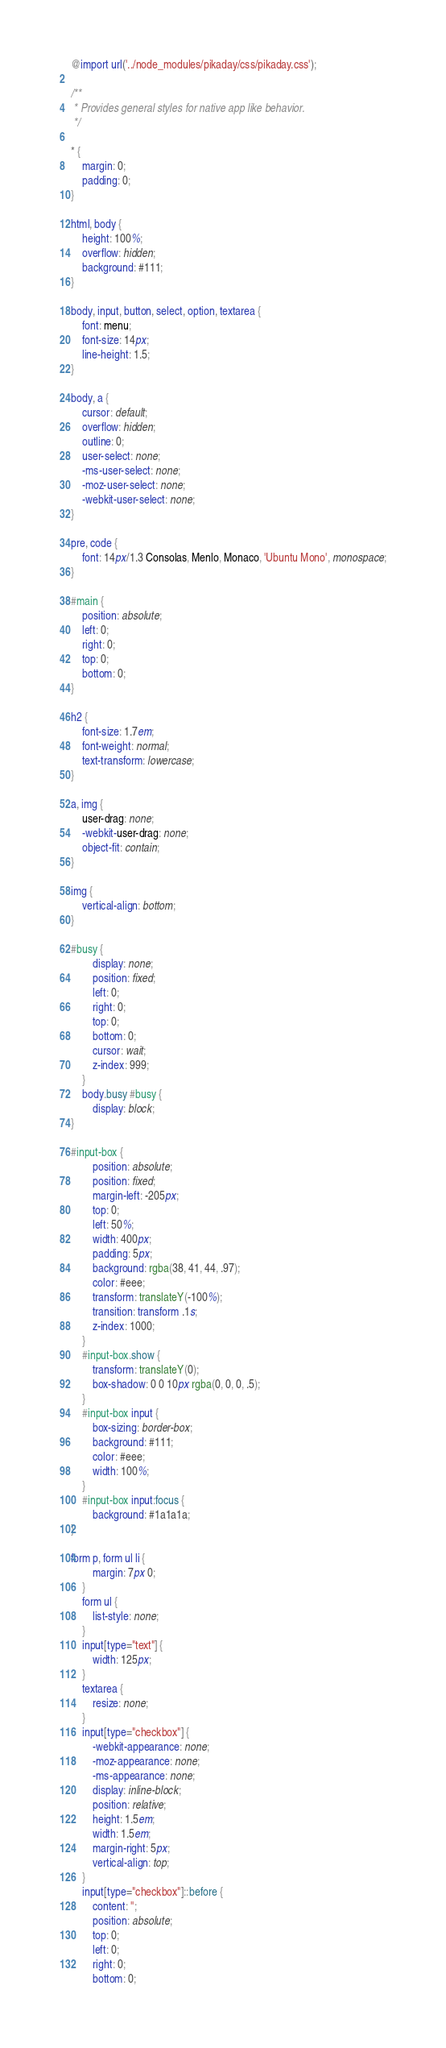<code> <loc_0><loc_0><loc_500><loc_500><_CSS_>@import url('../node_modules/pikaday/css/pikaday.css');

/**
 * Provides general styles for native app like behavior.
 */

* {
    margin: 0;
    padding: 0;
}

html, body {
    height: 100%;
    overflow: hidden;
    background: #111;
}

body, input, button, select, option, textarea {
    font: menu;
    font-size: 14px;
    line-height: 1.5;
}

body, a {
    cursor: default;
    overflow: hidden;
    outline: 0;
    user-select: none;
    -ms-user-select: none;
    -moz-user-select: none;
    -webkit-user-select: none;
}

pre, code {
    font: 14px/1.3 Consolas, Menlo, Monaco, 'Ubuntu Mono', monospace;
}

#main {
    position: absolute;
    left: 0;
    right: 0;
    top: 0;
    bottom: 0;
}

h2 {
    font-size: 1.7em;
    font-weight: normal;
    text-transform: lowercase;
}

a, img {
    user-drag: none;
    -webkit-user-drag: none;
    object-fit: contain;
}

img {
    vertical-align: bottom;
}

#busy {
        display: none;
        position: fixed;
        left: 0;
        right: 0;
        top: 0;
        bottom: 0;
        cursor: wait;
        z-index: 999;
    }
    body.busy #busy {
        display: block;
}

#input-box {
        position: absolute;
        position: fixed;
        margin-left: -205px;
        top: 0;
        left: 50%;
        width: 400px;
        padding: 5px;
        background: rgba(38, 41, 44, .97);
        color: #eee;
        transform: translateY(-100%);
        transition: transform .1s;
        z-index: 1000;
    }
    #input-box.show {
        transform: translateY(0);
        box-shadow: 0 0 10px rgba(0, 0, 0, .5);
    }
    #input-box input {
        box-sizing: border-box;
        background: #111;
        color: #eee;
        width: 100%;
    }
    #input-box input:focus {
        background: #1a1a1a;
}

form p, form ul li {
        margin: 7px 0;
    }
    form ul {
        list-style: none;
    }
    input[type="text"] {
        width: 125px;
    }
    textarea {
        resize: none;
    }
    input[type="checkbox"] {
        -webkit-appearance: none;
        -moz-appearance: none;
        -ms-appearance: none;
        display: inline-block;
        position: relative;
        height: 1.5em;
        width: 1.5em;
        margin-right: 5px;
        vertical-align: top;
    }
    input[type="checkbox"]::before {
        content: '';
        position: absolute;
        top: 0;
        left: 0;
        right: 0;
        bottom: 0;</code> 